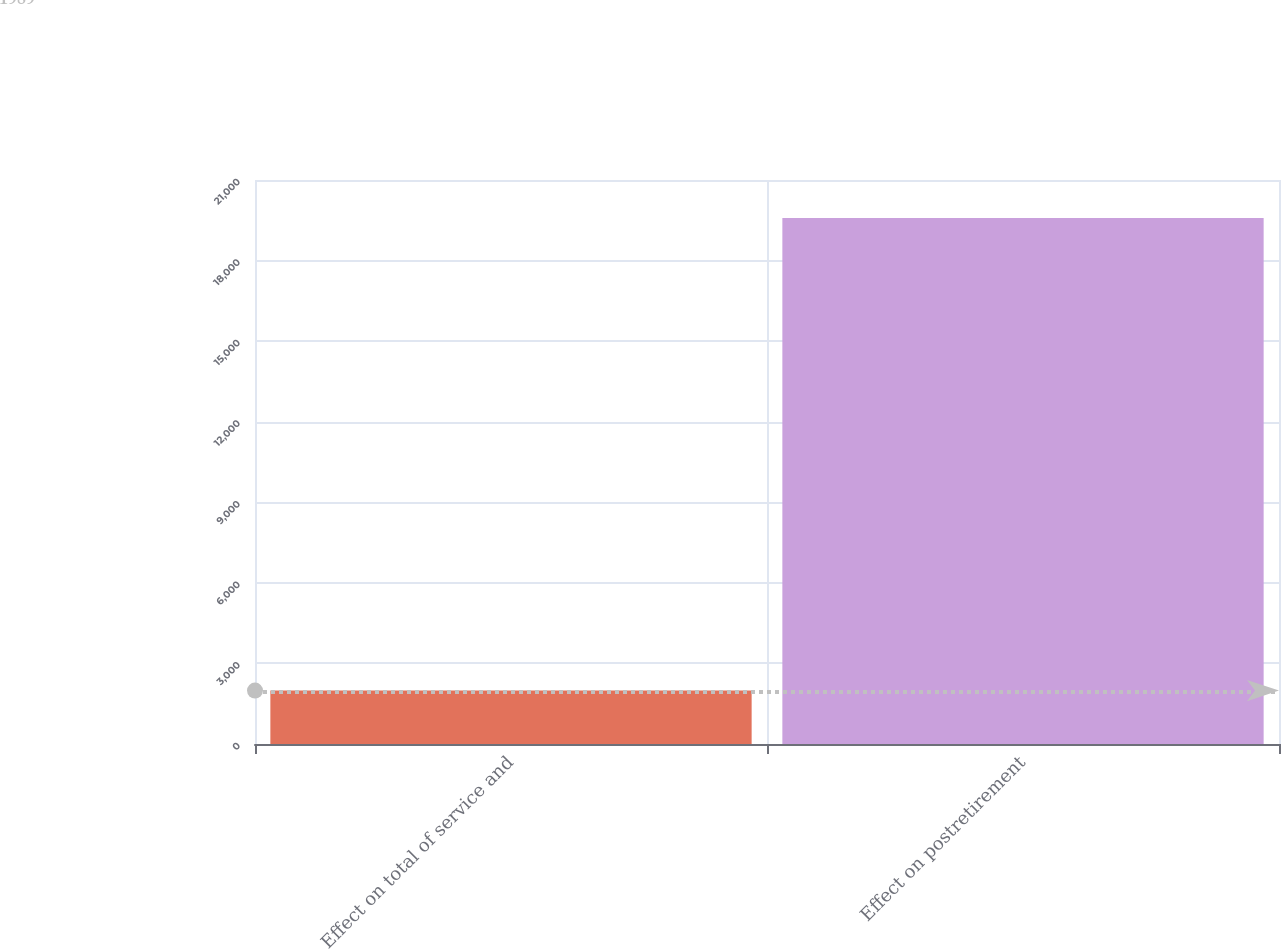<chart> <loc_0><loc_0><loc_500><loc_500><bar_chart><fcel>Effect on total of service and<fcel>Effect on postretirement<nl><fcel>1989<fcel>19585<nl></chart> 